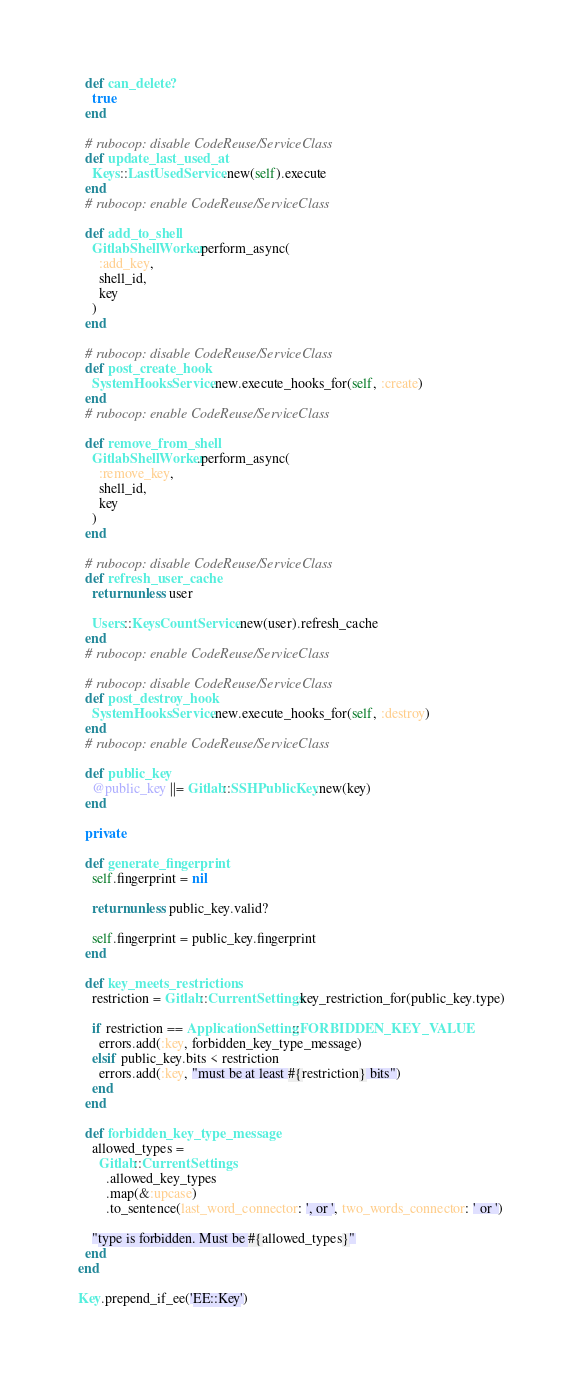Convert code to text. <code><loc_0><loc_0><loc_500><loc_500><_Ruby_>  def can_delete?
    true
  end

  # rubocop: disable CodeReuse/ServiceClass
  def update_last_used_at
    Keys::LastUsedService.new(self).execute
  end
  # rubocop: enable CodeReuse/ServiceClass

  def add_to_shell
    GitlabShellWorker.perform_async(
      :add_key,
      shell_id,
      key
    )
  end

  # rubocop: disable CodeReuse/ServiceClass
  def post_create_hook
    SystemHooksService.new.execute_hooks_for(self, :create)
  end
  # rubocop: enable CodeReuse/ServiceClass

  def remove_from_shell
    GitlabShellWorker.perform_async(
      :remove_key,
      shell_id,
      key
    )
  end

  # rubocop: disable CodeReuse/ServiceClass
  def refresh_user_cache
    return unless user

    Users::KeysCountService.new(user).refresh_cache
  end
  # rubocop: enable CodeReuse/ServiceClass

  # rubocop: disable CodeReuse/ServiceClass
  def post_destroy_hook
    SystemHooksService.new.execute_hooks_for(self, :destroy)
  end
  # rubocop: enable CodeReuse/ServiceClass

  def public_key
    @public_key ||= Gitlab::SSHPublicKey.new(key)
  end

  private

  def generate_fingerprint
    self.fingerprint = nil

    return unless public_key.valid?

    self.fingerprint = public_key.fingerprint
  end

  def key_meets_restrictions
    restriction = Gitlab::CurrentSettings.key_restriction_for(public_key.type)

    if restriction == ApplicationSetting::FORBIDDEN_KEY_VALUE
      errors.add(:key, forbidden_key_type_message)
    elsif public_key.bits < restriction
      errors.add(:key, "must be at least #{restriction} bits")
    end
  end

  def forbidden_key_type_message
    allowed_types =
      Gitlab::CurrentSettings
        .allowed_key_types
        .map(&:upcase)
        .to_sentence(last_word_connector: ', or ', two_words_connector: ' or ')

    "type is forbidden. Must be #{allowed_types}"
  end
end

Key.prepend_if_ee('EE::Key')
</code> 